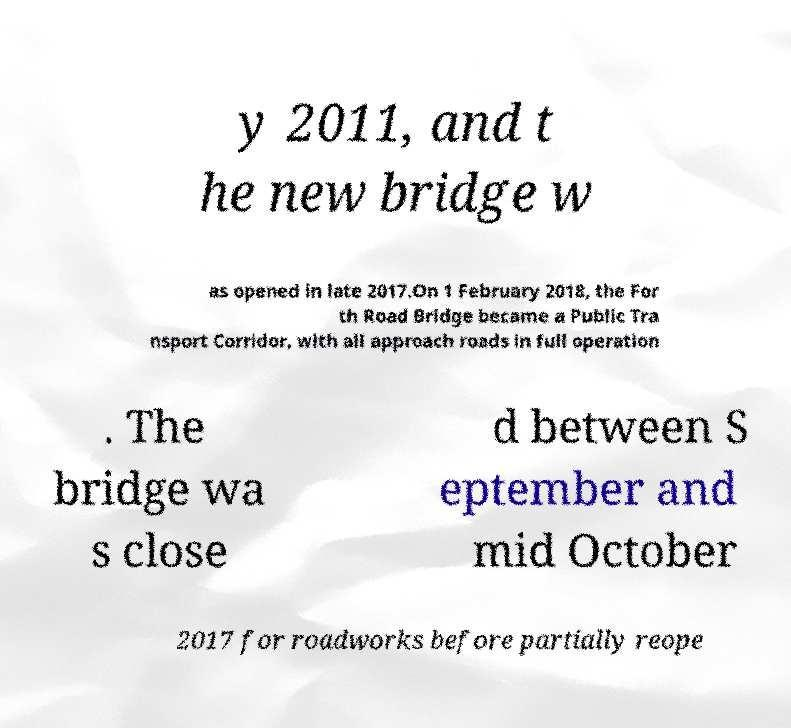Please read and relay the text visible in this image. What does it say? y 2011, and t he new bridge w as opened in late 2017.On 1 February 2018, the For th Road Bridge became a Public Tra nsport Corridor, with all approach roads in full operation . The bridge wa s close d between S eptember and mid October 2017 for roadworks before partially reope 